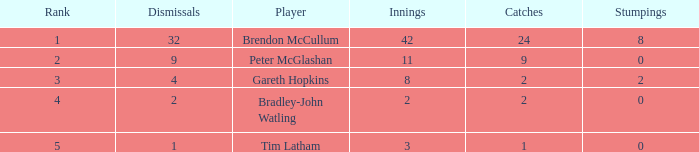What is the number of innings with a total of 2 catches and zero stumpings? 1.0. Would you mind parsing the complete table? {'header': ['Rank', 'Dismissals', 'Player', 'Innings', 'Catches', 'Stumpings'], 'rows': [['1', '32', 'Brendon McCullum', '42', '24', '8'], ['2', '9', 'Peter McGlashan', '11', '9', '0'], ['3', '4', 'Gareth Hopkins', '8', '2', '2'], ['4', '2', 'Bradley-John Watling', '2', '2', '0'], ['5', '1', 'Tim Latham', '3', '1', '0']]} 